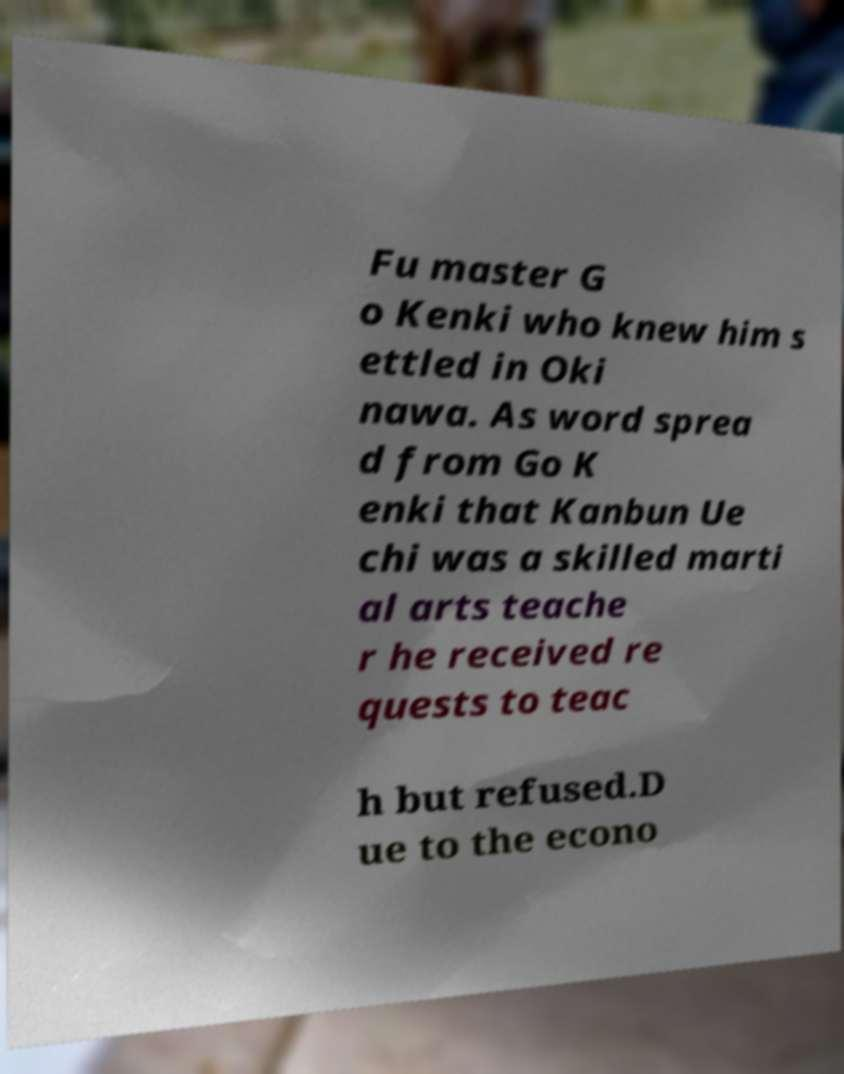I need the written content from this picture converted into text. Can you do that? Fu master G o Kenki who knew him s ettled in Oki nawa. As word sprea d from Go K enki that Kanbun Ue chi was a skilled marti al arts teache r he received re quests to teac h but refused.D ue to the econo 